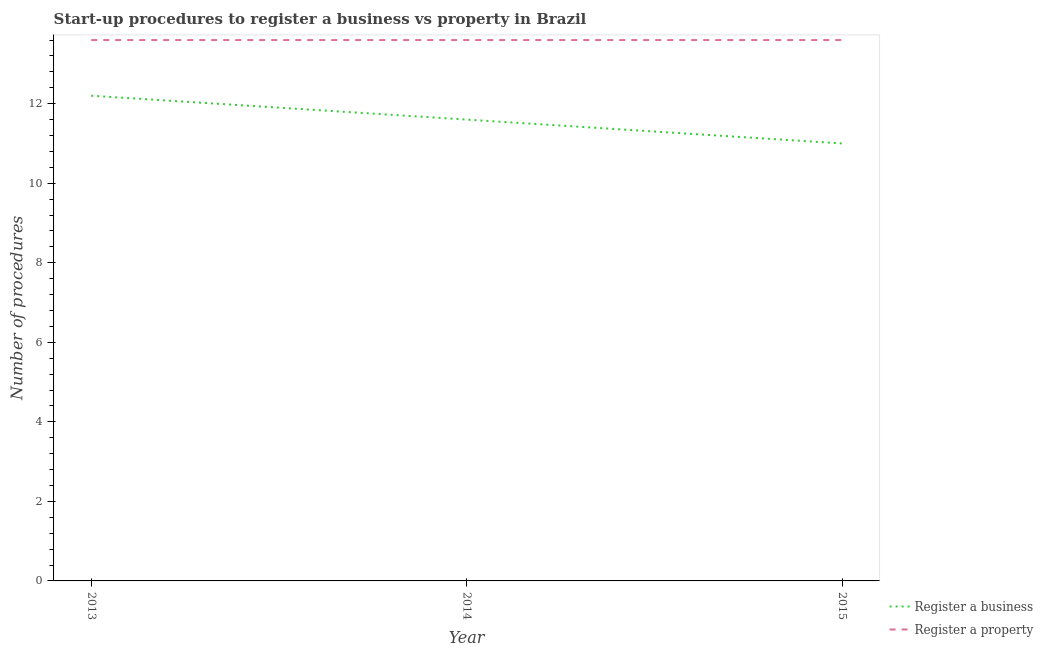How many different coloured lines are there?
Your answer should be compact. 2. What is the number of procedures to register a business in 2013?
Keep it short and to the point. 12.2. In which year was the number of procedures to register a business minimum?
Keep it short and to the point. 2015. What is the total number of procedures to register a property in the graph?
Offer a very short reply. 40.8. What is the difference between the number of procedures to register a property in 2013 and that in 2015?
Offer a terse response. 0. What is the difference between the number of procedures to register a business in 2015 and the number of procedures to register a property in 2013?
Provide a succinct answer. -2.6. What is the average number of procedures to register a property per year?
Offer a very short reply. 13.6. What is the ratio of the number of procedures to register a property in 2013 to that in 2015?
Provide a succinct answer. 1. Is the number of procedures to register a property in 2013 less than that in 2014?
Give a very brief answer. No. Is the difference between the number of procedures to register a property in 2014 and 2015 greater than the difference between the number of procedures to register a business in 2014 and 2015?
Ensure brevity in your answer.  No. What is the difference between the highest and the lowest number of procedures to register a property?
Give a very brief answer. 0. In how many years, is the number of procedures to register a business greater than the average number of procedures to register a business taken over all years?
Ensure brevity in your answer.  1. Does the number of procedures to register a business monotonically increase over the years?
Make the answer very short. No. Is the number of procedures to register a property strictly greater than the number of procedures to register a business over the years?
Your answer should be very brief. Yes. How many lines are there?
Offer a very short reply. 2. How many years are there in the graph?
Provide a short and direct response. 3. What is the difference between two consecutive major ticks on the Y-axis?
Your response must be concise. 2. Does the graph contain any zero values?
Ensure brevity in your answer.  No. Where does the legend appear in the graph?
Offer a very short reply. Bottom right. What is the title of the graph?
Make the answer very short. Start-up procedures to register a business vs property in Brazil. Does "Diarrhea" appear as one of the legend labels in the graph?
Make the answer very short. No. What is the label or title of the Y-axis?
Give a very brief answer. Number of procedures. What is the Number of procedures in Register a business in 2013?
Provide a short and direct response. 12.2. What is the Number of procedures of Register a property in 2013?
Provide a short and direct response. 13.6. What is the Number of procedures in Register a business in 2015?
Your response must be concise. 11. Across all years, what is the minimum Number of procedures in Register a business?
Offer a very short reply. 11. Across all years, what is the minimum Number of procedures in Register a property?
Your response must be concise. 13.6. What is the total Number of procedures of Register a business in the graph?
Offer a terse response. 34.8. What is the total Number of procedures in Register a property in the graph?
Offer a terse response. 40.8. What is the difference between the Number of procedures of Register a business in 2013 and that in 2015?
Your answer should be compact. 1.2. What is the difference between the Number of procedures of Register a property in 2013 and that in 2015?
Ensure brevity in your answer.  0. What is the difference between the Number of procedures of Register a property in 2014 and that in 2015?
Offer a terse response. 0. What is the difference between the Number of procedures of Register a business in 2013 and the Number of procedures of Register a property in 2015?
Offer a terse response. -1.4. What is the average Number of procedures of Register a property per year?
Provide a short and direct response. 13.6. What is the ratio of the Number of procedures of Register a business in 2013 to that in 2014?
Provide a short and direct response. 1.05. What is the ratio of the Number of procedures in Register a property in 2013 to that in 2014?
Provide a short and direct response. 1. What is the ratio of the Number of procedures in Register a business in 2013 to that in 2015?
Your response must be concise. 1.11. What is the ratio of the Number of procedures of Register a property in 2013 to that in 2015?
Give a very brief answer. 1. What is the ratio of the Number of procedures in Register a business in 2014 to that in 2015?
Provide a short and direct response. 1.05. What is the difference between the highest and the second highest Number of procedures of Register a business?
Keep it short and to the point. 0.6. 